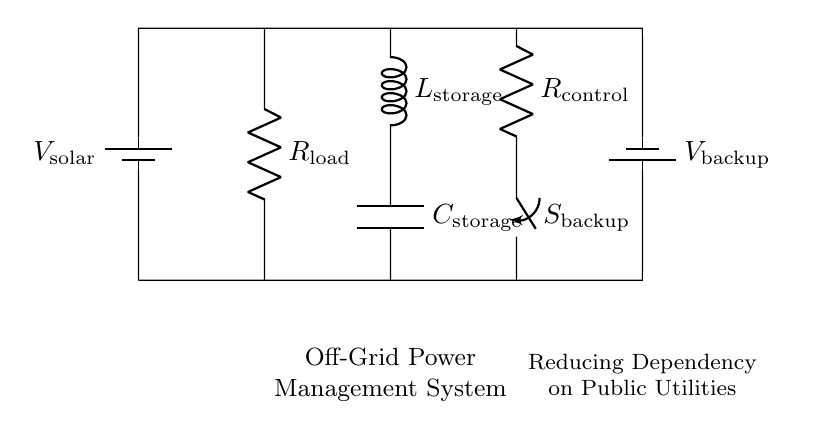What type of components are present in this circuit? The circuit includes resistors, an inductor, and a capacitor, which are the core components of an RLC circuit.
Answer: resistor, inductor, capacitor What is the purpose of the switch in the circuit? The switch, labeled as $S_{backup}$, is used to control the connection to the backup battery, allowing or disconnecting it based on the power needs.
Answer: control backup power What are the two voltage sources illustrated in the circuit? The circuit shows two batteries labeled $V_{solar}$ and $V_{backup}$, providing power from solar energy and backup energy, respectively.
Answer: solar, backup How does the inductor function in this off-grid system? The inductor, labeled as $L_{storage}$, stores energy in the magnetic field when current flows through it, helping to balance load variations and smooth the power supply.
Answer: energy storage What is the load resistor in the circuit? The load resistor is labeled $R_{load}$ and represents the resistance that is connected to the power supply, consuming power based on the current flowing through it.
Answer: R_load Why is a capacitor included in this off-grid power system? The capacitor, represented as $C_{storage}$, serves to store electrical energy and smooth out voltage fluctuations, enhancing the stability of the power supply.
Answer: voltage stabilization What is the overall goal of this circuit design? The circuit aims to create an off-grid power management system, reducing reliance on public utilities by utilizing solar energy and backup power.
Answer: reduce dependency on utilities 